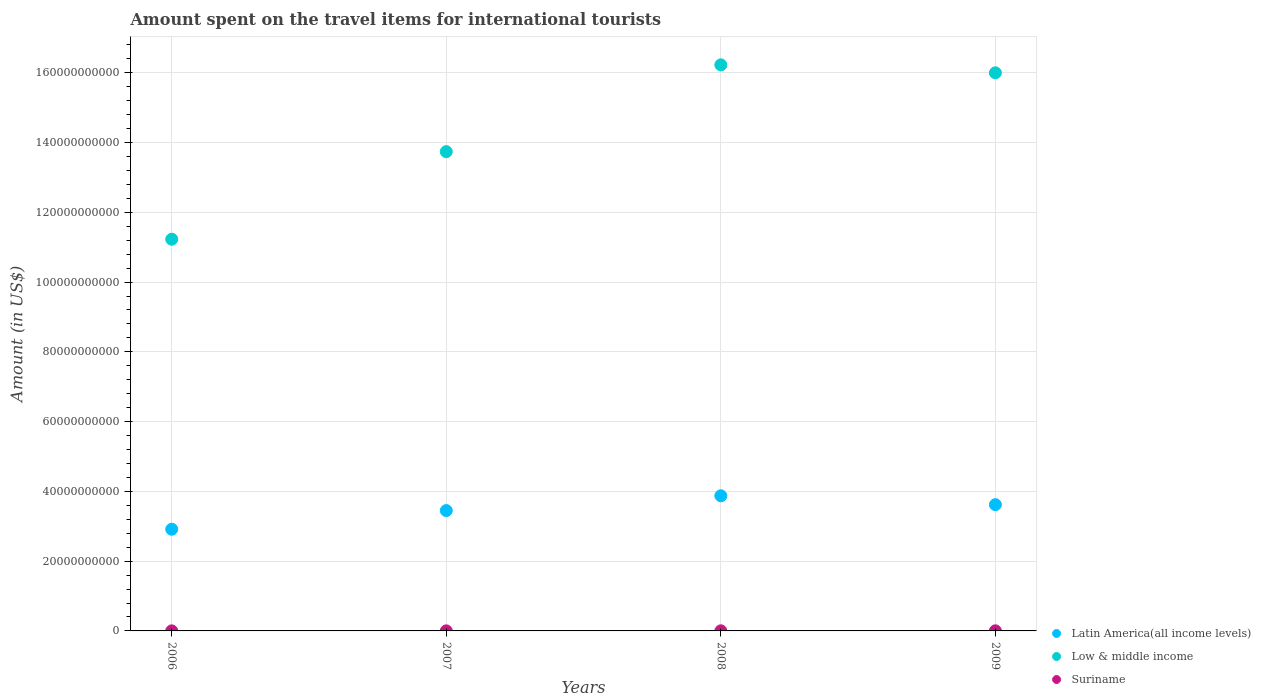Is the number of dotlines equal to the number of legend labels?
Your response must be concise. Yes. What is the amount spent on the travel items for international tourists in Latin America(all income levels) in 2007?
Keep it short and to the point. 3.45e+1. Across all years, what is the maximum amount spent on the travel items for international tourists in Suriname?
Your answer should be compact. 3.20e+07. Across all years, what is the minimum amount spent on the travel items for international tourists in Low & middle income?
Ensure brevity in your answer.  1.12e+11. What is the total amount spent on the travel items for international tourists in Low & middle income in the graph?
Your answer should be very brief. 5.72e+11. What is the difference between the amount spent on the travel items for international tourists in Low & middle income in 2006 and that in 2008?
Your response must be concise. -5.00e+1. What is the difference between the amount spent on the travel items for international tourists in Latin America(all income levels) in 2008 and the amount spent on the travel items for international tourists in Suriname in 2009?
Your answer should be very brief. 3.87e+1. What is the average amount spent on the travel items for international tourists in Suriname per year?
Your answer should be compact. 2.55e+07. In the year 2008, what is the difference between the amount spent on the travel items for international tourists in Latin America(all income levels) and amount spent on the travel items for international tourists in Low & middle income?
Provide a short and direct response. -1.24e+11. In how many years, is the amount spent on the travel items for international tourists in Suriname greater than 88000000000 US$?
Offer a very short reply. 0. What is the ratio of the amount spent on the travel items for international tourists in Low & middle income in 2006 to that in 2008?
Offer a terse response. 0.69. Is the amount spent on the travel items for international tourists in Suriname in 2007 less than that in 2009?
Your response must be concise. Yes. Is the difference between the amount spent on the travel items for international tourists in Latin America(all income levels) in 2008 and 2009 greater than the difference between the amount spent on the travel items for international tourists in Low & middle income in 2008 and 2009?
Keep it short and to the point. Yes. What is the difference between the highest and the second highest amount spent on the travel items for international tourists in Suriname?
Offer a very short reply. 2.00e+06. What is the difference between the highest and the lowest amount spent on the travel items for international tourists in Latin America(all income levels)?
Your response must be concise. 9.59e+09. Is the amount spent on the travel items for international tourists in Low & middle income strictly less than the amount spent on the travel items for international tourists in Suriname over the years?
Make the answer very short. No. How many years are there in the graph?
Your answer should be very brief. 4. Are the values on the major ticks of Y-axis written in scientific E-notation?
Your answer should be compact. No. Does the graph contain any zero values?
Offer a very short reply. No. Does the graph contain grids?
Give a very brief answer. Yes. How are the legend labels stacked?
Make the answer very short. Vertical. What is the title of the graph?
Offer a very short reply. Amount spent on the travel items for international tourists. Does "North America" appear as one of the legend labels in the graph?
Ensure brevity in your answer.  No. What is the label or title of the X-axis?
Your response must be concise. Years. What is the label or title of the Y-axis?
Your response must be concise. Amount (in US$). What is the Amount (in US$) in Latin America(all income levels) in 2006?
Offer a very short reply. 2.92e+1. What is the Amount (in US$) in Low & middle income in 2006?
Offer a terse response. 1.12e+11. What is the Amount (in US$) of Suriname in 2006?
Your answer should be compact. 1.80e+07. What is the Amount (in US$) in Latin America(all income levels) in 2007?
Ensure brevity in your answer.  3.45e+1. What is the Amount (in US$) of Low & middle income in 2007?
Offer a very short reply. 1.37e+11. What is the Amount (in US$) of Suriname in 2007?
Provide a succinct answer. 2.20e+07. What is the Amount (in US$) of Latin America(all income levels) in 2008?
Offer a terse response. 3.87e+1. What is the Amount (in US$) in Low & middle income in 2008?
Offer a very short reply. 1.62e+11. What is the Amount (in US$) in Suriname in 2008?
Provide a succinct answer. 3.00e+07. What is the Amount (in US$) of Latin America(all income levels) in 2009?
Provide a short and direct response. 3.62e+1. What is the Amount (in US$) in Low & middle income in 2009?
Offer a very short reply. 1.60e+11. What is the Amount (in US$) in Suriname in 2009?
Ensure brevity in your answer.  3.20e+07. Across all years, what is the maximum Amount (in US$) in Latin America(all income levels)?
Your answer should be compact. 3.87e+1. Across all years, what is the maximum Amount (in US$) of Low & middle income?
Provide a succinct answer. 1.62e+11. Across all years, what is the maximum Amount (in US$) in Suriname?
Provide a short and direct response. 3.20e+07. Across all years, what is the minimum Amount (in US$) of Latin America(all income levels)?
Make the answer very short. 2.92e+1. Across all years, what is the minimum Amount (in US$) of Low & middle income?
Keep it short and to the point. 1.12e+11. Across all years, what is the minimum Amount (in US$) of Suriname?
Provide a succinct answer. 1.80e+07. What is the total Amount (in US$) in Latin America(all income levels) in the graph?
Offer a terse response. 1.39e+11. What is the total Amount (in US$) of Low & middle income in the graph?
Keep it short and to the point. 5.72e+11. What is the total Amount (in US$) of Suriname in the graph?
Offer a terse response. 1.02e+08. What is the difference between the Amount (in US$) of Latin America(all income levels) in 2006 and that in 2007?
Make the answer very short. -5.35e+09. What is the difference between the Amount (in US$) of Low & middle income in 2006 and that in 2007?
Offer a very short reply. -2.51e+1. What is the difference between the Amount (in US$) of Latin America(all income levels) in 2006 and that in 2008?
Give a very brief answer. -9.59e+09. What is the difference between the Amount (in US$) of Low & middle income in 2006 and that in 2008?
Your response must be concise. -5.00e+1. What is the difference between the Amount (in US$) in Suriname in 2006 and that in 2008?
Make the answer very short. -1.20e+07. What is the difference between the Amount (in US$) of Latin America(all income levels) in 2006 and that in 2009?
Give a very brief answer. -7.04e+09. What is the difference between the Amount (in US$) in Low & middle income in 2006 and that in 2009?
Offer a terse response. -4.77e+1. What is the difference between the Amount (in US$) in Suriname in 2006 and that in 2009?
Offer a very short reply. -1.40e+07. What is the difference between the Amount (in US$) in Latin America(all income levels) in 2007 and that in 2008?
Keep it short and to the point. -4.24e+09. What is the difference between the Amount (in US$) of Low & middle income in 2007 and that in 2008?
Give a very brief answer. -2.49e+1. What is the difference between the Amount (in US$) of Suriname in 2007 and that in 2008?
Your response must be concise. -8.00e+06. What is the difference between the Amount (in US$) of Latin America(all income levels) in 2007 and that in 2009?
Provide a short and direct response. -1.70e+09. What is the difference between the Amount (in US$) of Low & middle income in 2007 and that in 2009?
Offer a very short reply. -2.26e+1. What is the difference between the Amount (in US$) in Suriname in 2007 and that in 2009?
Offer a very short reply. -1.00e+07. What is the difference between the Amount (in US$) of Latin America(all income levels) in 2008 and that in 2009?
Provide a short and direct response. 2.54e+09. What is the difference between the Amount (in US$) of Low & middle income in 2008 and that in 2009?
Your response must be concise. 2.27e+09. What is the difference between the Amount (in US$) of Suriname in 2008 and that in 2009?
Ensure brevity in your answer.  -2.00e+06. What is the difference between the Amount (in US$) of Latin America(all income levels) in 2006 and the Amount (in US$) of Low & middle income in 2007?
Your answer should be compact. -1.08e+11. What is the difference between the Amount (in US$) of Latin America(all income levels) in 2006 and the Amount (in US$) of Suriname in 2007?
Give a very brief answer. 2.91e+1. What is the difference between the Amount (in US$) of Low & middle income in 2006 and the Amount (in US$) of Suriname in 2007?
Keep it short and to the point. 1.12e+11. What is the difference between the Amount (in US$) of Latin America(all income levels) in 2006 and the Amount (in US$) of Low & middle income in 2008?
Ensure brevity in your answer.  -1.33e+11. What is the difference between the Amount (in US$) of Latin America(all income levels) in 2006 and the Amount (in US$) of Suriname in 2008?
Make the answer very short. 2.91e+1. What is the difference between the Amount (in US$) of Low & middle income in 2006 and the Amount (in US$) of Suriname in 2008?
Offer a terse response. 1.12e+11. What is the difference between the Amount (in US$) of Latin America(all income levels) in 2006 and the Amount (in US$) of Low & middle income in 2009?
Provide a short and direct response. -1.31e+11. What is the difference between the Amount (in US$) in Latin America(all income levels) in 2006 and the Amount (in US$) in Suriname in 2009?
Offer a terse response. 2.91e+1. What is the difference between the Amount (in US$) in Low & middle income in 2006 and the Amount (in US$) in Suriname in 2009?
Your answer should be very brief. 1.12e+11. What is the difference between the Amount (in US$) in Latin America(all income levels) in 2007 and the Amount (in US$) in Low & middle income in 2008?
Ensure brevity in your answer.  -1.28e+11. What is the difference between the Amount (in US$) of Latin America(all income levels) in 2007 and the Amount (in US$) of Suriname in 2008?
Give a very brief answer. 3.45e+1. What is the difference between the Amount (in US$) in Low & middle income in 2007 and the Amount (in US$) in Suriname in 2008?
Your answer should be very brief. 1.37e+11. What is the difference between the Amount (in US$) of Latin America(all income levels) in 2007 and the Amount (in US$) of Low & middle income in 2009?
Give a very brief answer. -1.25e+11. What is the difference between the Amount (in US$) in Latin America(all income levels) in 2007 and the Amount (in US$) in Suriname in 2009?
Ensure brevity in your answer.  3.45e+1. What is the difference between the Amount (in US$) of Low & middle income in 2007 and the Amount (in US$) of Suriname in 2009?
Your answer should be very brief. 1.37e+11. What is the difference between the Amount (in US$) of Latin America(all income levels) in 2008 and the Amount (in US$) of Low & middle income in 2009?
Keep it short and to the point. -1.21e+11. What is the difference between the Amount (in US$) of Latin America(all income levels) in 2008 and the Amount (in US$) of Suriname in 2009?
Provide a short and direct response. 3.87e+1. What is the difference between the Amount (in US$) in Low & middle income in 2008 and the Amount (in US$) in Suriname in 2009?
Make the answer very short. 1.62e+11. What is the average Amount (in US$) in Latin America(all income levels) per year?
Keep it short and to the point. 3.46e+1. What is the average Amount (in US$) of Low & middle income per year?
Give a very brief answer. 1.43e+11. What is the average Amount (in US$) in Suriname per year?
Offer a very short reply. 2.55e+07. In the year 2006, what is the difference between the Amount (in US$) of Latin America(all income levels) and Amount (in US$) of Low & middle income?
Give a very brief answer. -8.31e+1. In the year 2006, what is the difference between the Amount (in US$) of Latin America(all income levels) and Amount (in US$) of Suriname?
Your response must be concise. 2.91e+1. In the year 2006, what is the difference between the Amount (in US$) in Low & middle income and Amount (in US$) in Suriname?
Your answer should be very brief. 1.12e+11. In the year 2007, what is the difference between the Amount (in US$) in Latin America(all income levels) and Amount (in US$) in Low & middle income?
Give a very brief answer. -1.03e+11. In the year 2007, what is the difference between the Amount (in US$) in Latin America(all income levels) and Amount (in US$) in Suriname?
Make the answer very short. 3.45e+1. In the year 2007, what is the difference between the Amount (in US$) of Low & middle income and Amount (in US$) of Suriname?
Make the answer very short. 1.37e+11. In the year 2008, what is the difference between the Amount (in US$) of Latin America(all income levels) and Amount (in US$) of Low & middle income?
Your answer should be compact. -1.24e+11. In the year 2008, what is the difference between the Amount (in US$) in Latin America(all income levels) and Amount (in US$) in Suriname?
Provide a succinct answer. 3.87e+1. In the year 2008, what is the difference between the Amount (in US$) of Low & middle income and Amount (in US$) of Suriname?
Ensure brevity in your answer.  1.62e+11. In the year 2009, what is the difference between the Amount (in US$) of Latin America(all income levels) and Amount (in US$) of Low & middle income?
Provide a short and direct response. -1.24e+11. In the year 2009, what is the difference between the Amount (in US$) of Latin America(all income levels) and Amount (in US$) of Suriname?
Provide a short and direct response. 3.62e+1. In the year 2009, what is the difference between the Amount (in US$) in Low & middle income and Amount (in US$) in Suriname?
Offer a very short reply. 1.60e+11. What is the ratio of the Amount (in US$) of Latin America(all income levels) in 2006 to that in 2007?
Offer a very short reply. 0.84. What is the ratio of the Amount (in US$) in Low & middle income in 2006 to that in 2007?
Ensure brevity in your answer.  0.82. What is the ratio of the Amount (in US$) of Suriname in 2006 to that in 2007?
Offer a very short reply. 0.82. What is the ratio of the Amount (in US$) of Latin America(all income levels) in 2006 to that in 2008?
Offer a terse response. 0.75. What is the ratio of the Amount (in US$) in Low & middle income in 2006 to that in 2008?
Offer a terse response. 0.69. What is the ratio of the Amount (in US$) of Latin America(all income levels) in 2006 to that in 2009?
Make the answer very short. 0.81. What is the ratio of the Amount (in US$) of Low & middle income in 2006 to that in 2009?
Ensure brevity in your answer.  0.7. What is the ratio of the Amount (in US$) of Suriname in 2006 to that in 2009?
Provide a succinct answer. 0.56. What is the ratio of the Amount (in US$) in Latin America(all income levels) in 2007 to that in 2008?
Ensure brevity in your answer.  0.89. What is the ratio of the Amount (in US$) of Low & middle income in 2007 to that in 2008?
Provide a succinct answer. 0.85. What is the ratio of the Amount (in US$) of Suriname in 2007 to that in 2008?
Give a very brief answer. 0.73. What is the ratio of the Amount (in US$) in Latin America(all income levels) in 2007 to that in 2009?
Provide a succinct answer. 0.95. What is the ratio of the Amount (in US$) in Low & middle income in 2007 to that in 2009?
Offer a very short reply. 0.86. What is the ratio of the Amount (in US$) in Suriname in 2007 to that in 2009?
Your answer should be very brief. 0.69. What is the ratio of the Amount (in US$) of Latin America(all income levels) in 2008 to that in 2009?
Keep it short and to the point. 1.07. What is the ratio of the Amount (in US$) of Low & middle income in 2008 to that in 2009?
Keep it short and to the point. 1.01. What is the difference between the highest and the second highest Amount (in US$) of Latin America(all income levels)?
Keep it short and to the point. 2.54e+09. What is the difference between the highest and the second highest Amount (in US$) in Low & middle income?
Offer a very short reply. 2.27e+09. What is the difference between the highest and the second highest Amount (in US$) in Suriname?
Keep it short and to the point. 2.00e+06. What is the difference between the highest and the lowest Amount (in US$) of Latin America(all income levels)?
Your answer should be very brief. 9.59e+09. What is the difference between the highest and the lowest Amount (in US$) of Low & middle income?
Offer a very short reply. 5.00e+1. What is the difference between the highest and the lowest Amount (in US$) in Suriname?
Offer a very short reply. 1.40e+07. 